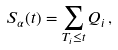Convert formula to latex. <formula><loc_0><loc_0><loc_500><loc_500>S _ { \alpha } ( t ) = \sum _ { T _ { i } \leq t } Q _ { i } \, ,</formula> 